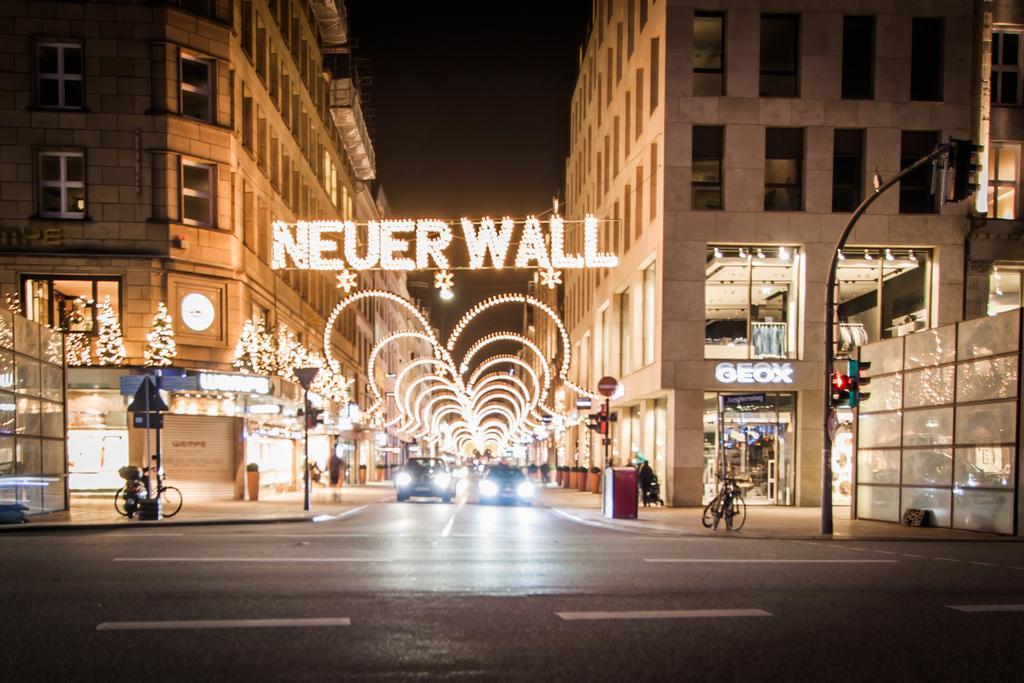In one or two sentences, can you explain what this image depicts? In this image we can see a road. On road two cars are moving. To the both side of the road buildings are there. In front of the building pavement is there. On pavement bicycle, poles and some plants are there. 